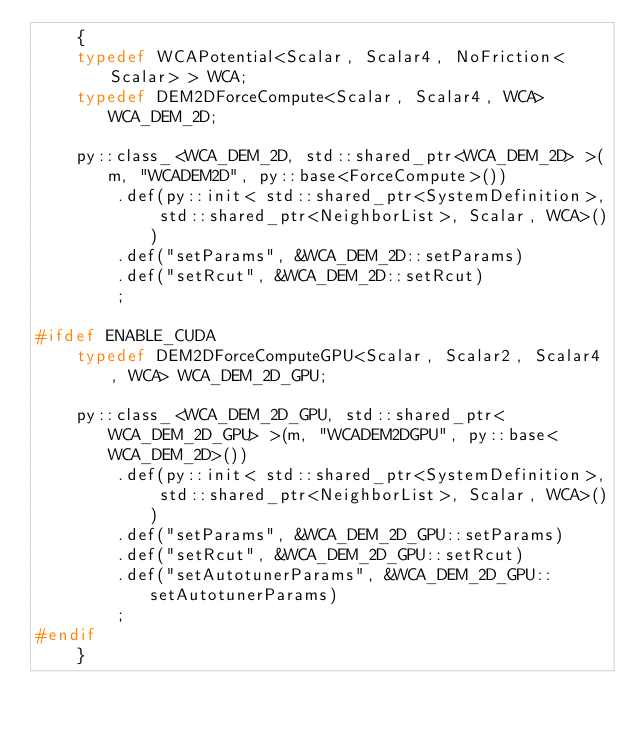Convert code to text. <code><loc_0><loc_0><loc_500><loc_500><_C++_>    {
    typedef WCAPotential<Scalar, Scalar4, NoFriction<Scalar> > WCA;
    typedef DEM2DForceCompute<Scalar, Scalar4, WCA> WCA_DEM_2D;

    py::class_<WCA_DEM_2D, std::shared_ptr<WCA_DEM_2D> >(m, "WCADEM2D", py::base<ForceCompute>())
        .def(py::init< std::shared_ptr<SystemDefinition>, std::shared_ptr<NeighborList>, Scalar, WCA>())
        .def("setParams", &WCA_DEM_2D::setParams)
        .def("setRcut", &WCA_DEM_2D::setRcut)
        ;

#ifdef ENABLE_CUDA
    typedef DEM2DForceComputeGPU<Scalar, Scalar2, Scalar4, WCA> WCA_DEM_2D_GPU;

    py::class_<WCA_DEM_2D_GPU, std::shared_ptr<WCA_DEM_2D_GPU> >(m, "WCADEM2DGPU", py::base<WCA_DEM_2D>())
        .def(py::init< std::shared_ptr<SystemDefinition>, std::shared_ptr<NeighborList>, Scalar, WCA>())
        .def("setParams", &WCA_DEM_2D_GPU::setParams)
        .def("setRcut", &WCA_DEM_2D_GPU::setRcut)
        .def("setAutotunerParams", &WCA_DEM_2D_GPU::setAutotunerParams)
        ;
#endif
    }
</code> 